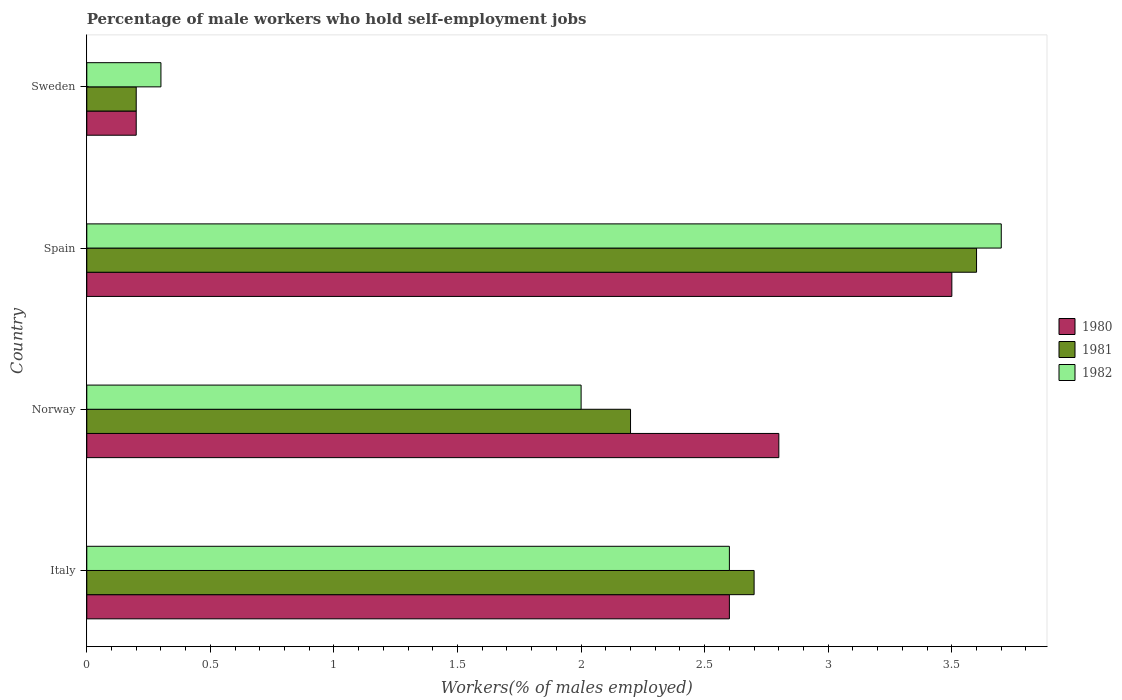How many different coloured bars are there?
Give a very brief answer. 3. What is the label of the 3rd group of bars from the top?
Your answer should be very brief. Norway. What is the percentage of self-employed male workers in 1981 in Norway?
Offer a very short reply. 2.2. Across all countries, what is the maximum percentage of self-employed male workers in 1982?
Provide a short and direct response. 3.7. Across all countries, what is the minimum percentage of self-employed male workers in 1982?
Your answer should be compact. 0.3. In which country was the percentage of self-employed male workers in 1980 minimum?
Offer a terse response. Sweden. What is the total percentage of self-employed male workers in 1980 in the graph?
Your answer should be very brief. 9.1. What is the difference between the percentage of self-employed male workers in 1982 in Italy and that in Spain?
Ensure brevity in your answer.  -1.1. What is the difference between the percentage of self-employed male workers in 1982 in Norway and the percentage of self-employed male workers in 1981 in Sweden?
Your answer should be very brief. 1.8. What is the average percentage of self-employed male workers in 1982 per country?
Provide a succinct answer. 2.15. What is the difference between the percentage of self-employed male workers in 1981 and percentage of self-employed male workers in 1980 in Norway?
Offer a very short reply. -0.6. In how many countries, is the percentage of self-employed male workers in 1981 greater than 1.2 %?
Your response must be concise. 3. What is the ratio of the percentage of self-employed male workers in 1980 in Spain to that in Sweden?
Your answer should be very brief. 17.5. Is the difference between the percentage of self-employed male workers in 1981 in Norway and Sweden greater than the difference between the percentage of self-employed male workers in 1980 in Norway and Sweden?
Provide a short and direct response. No. What is the difference between the highest and the second highest percentage of self-employed male workers in 1981?
Provide a succinct answer. 0.9. What is the difference between the highest and the lowest percentage of self-employed male workers in 1980?
Make the answer very short. 3.3. What does the 2nd bar from the top in Italy represents?
Offer a terse response. 1981. What does the 2nd bar from the bottom in Spain represents?
Ensure brevity in your answer.  1981. How many bars are there?
Offer a terse response. 12. Are all the bars in the graph horizontal?
Your answer should be very brief. Yes. How many countries are there in the graph?
Make the answer very short. 4. What is the difference between two consecutive major ticks on the X-axis?
Keep it short and to the point. 0.5. Are the values on the major ticks of X-axis written in scientific E-notation?
Your answer should be compact. No. Does the graph contain any zero values?
Provide a short and direct response. No. Does the graph contain grids?
Provide a short and direct response. No. How many legend labels are there?
Keep it short and to the point. 3. What is the title of the graph?
Provide a short and direct response. Percentage of male workers who hold self-employment jobs. What is the label or title of the X-axis?
Make the answer very short. Workers(% of males employed). What is the Workers(% of males employed) in 1980 in Italy?
Your answer should be compact. 2.6. What is the Workers(% of males employed) in 1981 in Italy?
Keep it short and to the point. 2.7. What is the Workers(% of males employed) in 1982 in Italy?
Your answer should be compact. 2.6. What is the Workers(% of males employed) in 1980 in Norway?
Make the answer very short. 2.8. What is the Workers(% of males employed) in 1981 in Norway?
Make the answer very short. 2.2. What is the Workers(% of males employed) in 1981 in Spain?
Offer a terse response. 3.6. What is the Workers(% of males employed) in 1982 in Spain?
Give a very brief answer. 3.7. What is the Workers(% of males employed) of 1980 in Sweden?
Keep it short and to the point. 0.2. What is the Workers(% of males employed) of 1981 in Sweden?
Your answer should be very brief. 0.2. What is the Workers(% of males employed) of 1982 in Sweden?
Give a very brief answer. 0.3. Across all countries, what is the maximum Workers(% of males employed) of 1980?
Your answer should be compact. 3.5. Across all countries, what is the maximum Workers(% of males employed) of 1981?
Your response must be concise. 3.6. Across all countries, what is the maximum Workers(% of males employed) of 1982?
Provide a short and direct response. 3.7. Across all countries, what is the minimum Workers(% of males employed) of 1980?
Keep it short and to the point. 0.2. Across all countries, what is the minimum Workers(% of males employed) in 1981?
Your answer should be compact. 0.2. Across all countries, what is the minimum Workers(% of males employed) in 1982?
Your answer should be very brief. 0.3. What is the total Workers(% of males employed) of 1980 in the graph?
Offer a very short reply. 9.1. What is the difference between the Workers(% of males employed) in 1980 in Italy and that in Norway?
Give a very brief answer. -0.2. What is the difference between the Workers(% of males employed) of 1981 in Italy and that in Norway?
Provide a short and direct response. 0.5. What is the difference between the Workers(% of males employed) of 1981 in Italy and that in Spain?
Ensure brevity in your answer.  -0.9. What is the difference between the Workers(% of males employed) of 1982 in Italy and that in Spain?
Your response must be concise. -1.1. What is the difference between the Workers(% of males employed) in 1982 in Italy and that in Sweden?
Your response must be concise. 2.3. What is the difference between the Workers(% of males employed) in 1981 in Norway and that in Spain?
Your answer should be compact. -1.4. What is the difference between the Workers(% of males employed) in 1982 in Norway and that in Spain?
Offer a very short reply. -1.7. What is the difference between the Workers(% of males employed) of 1981 in Norway and that in Sweden?
Give a very brief answer. 2. What is the difference between the Workers(% of males employed) of 1982 in Norway and that in Sweden?
Offer a terse response. 1.7. What is the difference between the Workers(% of males employed) of 1981 in Spain and that in Sweden?
Provide a succinct answer. 3.4. What is the difference between the Workers(% of males employed) of 1980 in Italy and the Workers(% of males employed) of 1981 in Spain?
Offer a terse response. -1. What is the difference between the Workers(% of males employed) of 1981 in Italy and the Workers(% of males employed) of 1982 in Spain?
Your response must be concise. -1. What is the difference between the Workers(% of males employed) in 1980 in Italy and the Workers(% of males employed) in 1982 in Sweden?
Keep it short and to the point. 2.3. What is the difference between the Workers(% of males employed) of 1980 in Norway and the Workers(% of males employed) of 1982 in Spain?
Make the answer very short. -0.9. What is the difference between the Workers(% of males employed) of 1981 in Norway and the Workers(% of males employed) of 1982 in Spain?
Your answer should be very brief. -1.5. What is the difference between the Workers(% of males employed) in 1980 in Norway and the Workers(% of males employed) in 1982 in Sweden?
Offer a terse response. 2.5. What is the difference between the Workers(% of males employed) in 1980 in Spain and the Workers(% of males employed) in 1981 in Sweden?
Your answer should be compact. 3.3. What is the difference between the Workers(% of males employed) of 1981 in Spain and the Workers(% of males employed) of 1982 in Sweden?
Offer a terse response. 3.3. What is the average Workers(% of males employed) of 1980 per country?
Ensure brevity in your answer.  2.27. What is the average Workers(% of males employed) in 1981 per country?
Provide a short and direct response. 2.17. What is the average Workers(% of males employed) in 1982 per country?
Ensure brevity in your answer.  2.15. What is the difference between the Workers(% of males employed) of 1981 and Workers(% of males employed) of 1982 in Norway?
Keep it short and to the point. 0.2. What is the difference between the Workers(% of males employed) of 1981 and Workers(% of males employed) of 1982 in Sweden?
Your response must be concise. -0.1. What is the ratio of the Workers(% of males employed) of 1980 in Italy to that in Norway?
Offer a terse response. 0.93. What is the ratio of the Workers(% of males employed) of 1981 in Italy to that in Norway?
Give a very brief answer. 1.23. What is the ratio of the Workers(% of males employed) of 1982 in Italy to that in Norway?
Your answer should be very brief. 1.3. What is the ratio of the Workers(% of males employed) of 1980 in Italy to that in Spain?
Provide a succinct answer. 0.74. What is the ratio of the Workers(% of males employed) in 1982 in Italy to that in Spain?
Keep it short and to the point. 0.7. What is the ratio of the Workers(% of males employed) of 1982 in Italy to that in Sweden?
Your answer should be very brief. 8.67. What is the ratio of the Workers(% of males employed) in 1981 in Norway to that in Spain?
Provide a short and direct response. 0.61. What is the ratio of the Workers(% of males employed) in 1982 in Norway to that in Spain?
Your answer should be compact. 0.54. What is the ratio of the Workers(% of males employed) in 1981 in Norway to that in Sweden?
Make the answer very short. 11. What is the ratio of the Workers(% of males employed) of 1982 in Norway to that in Sweden?
Offer a terse response. 6.67. What is the ratio of the Workers(% of males employed) in 1980 in Spain to that in Sweden?
Offer a terse response. 17.5. What is the ratio of the Workers(% of males employed) of 1982 in Spain to that in Sweden?
Ensure brevity in your answer.  12.33. What is the difference between the highest and the second highest Workers(% of males employed) in 1980?
Your answer should be very brief. 0.7. What is the difference between the highest and the second highest Workers(% of males employed) of 1981?
Your answer should be compact. 0.9. What is the difference between the highest and the lowest Workers(% of males employed) in 1980?
Ensure brevity in your answer.  3.3. What is the difference between the highest and the lowest Workers(% of males employed) in 1982?
Your answer should be compact. 3.4. 